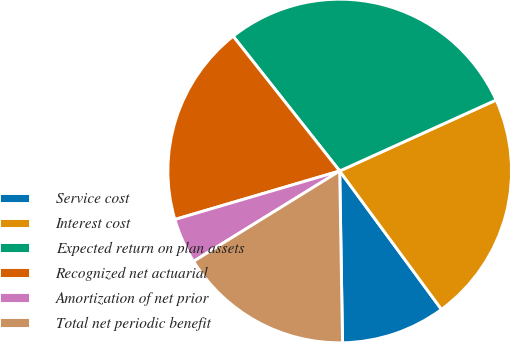Convert chart. <chart><loc_0><loc_0><loc_500><loc_500><pie_chart><fcel>Service cost<fcel>Interest cost<fcel>Expected return on plan assets<fcel>Recognized net actuarial<fcel>Amortization of net prior<fcel>Total net periodic benefit<nl><fcel>9.83%<fcel>21.69%<fcel>28.87%<fcel>18.91%<fcel>4.26%<fcel>16.45%<nl></chart> 